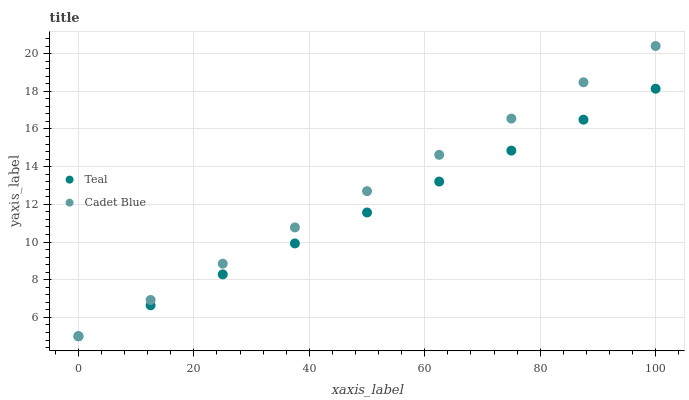Does Teal have the minimum area under the curve?
Answer yes or no. Yes. Does Cadet Blue have the maximum area under the curve?
Answer yes or no. Yes. Does Teal have the maximum area under the curve?
Answer yes or no. No. Is Cadet Blue the smoothest?
Answer yes or no. Yes. Is Teal the roughest?
Answer yes or no. Yes. Does Cadet Blue have the lowest value?
Answer yes or no. Yes. Does Cadet Blue have the highest value?
Answer yes or no. Yes. Does Teal have the highest value?
Answer yes or no. No. Does Cadet Blue intersect Teal?
Answer yes or no. Yes. Is Cadet Blue less than Teal?
Answer yes or no. No. Is Cadet Blue greater than Teal?
Answer yes or no. No. 